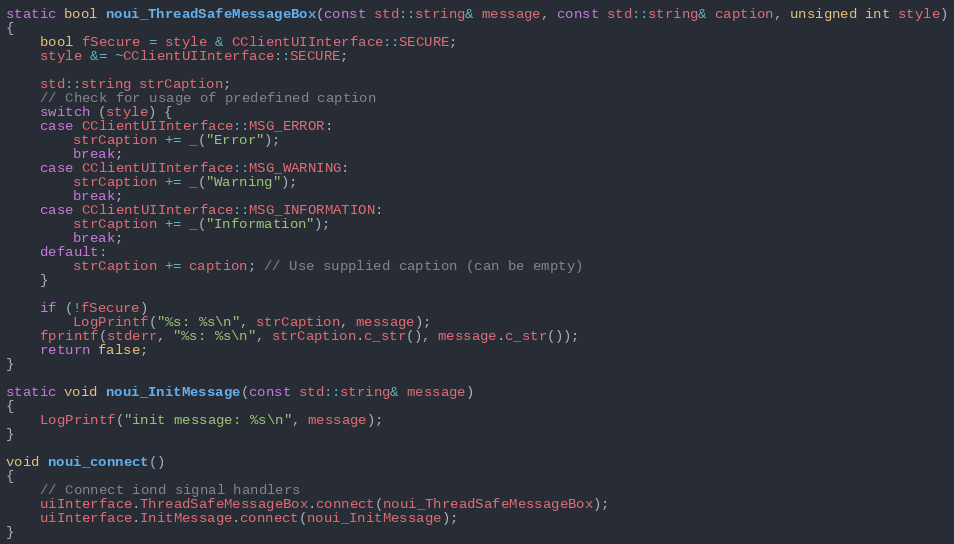Convert code to text. <code><loc_0><loc_0><loc_500><loc_500><_C++_>static bool noui_ThreadSafeMessageBox(const std::string& message, const std::string& caption, unsigned int style)
{
    bool fSecure = style & CClientUIInterface::SECURE;
    style &= ~CClientUIInterface::SECURE;

    std::string strCaption;
    // Check for usage of predefined caption
    switch (style) {
    case CClientUIInterface::MSG_ERROR:
        strCaption += _("Error");
        break;
    case CClientUIInterface::MSG_WARNING:
        strCaption += _("Warning");
        break;
    case CClientUIInterface::MSG_INFORMATION:
        strCaption += _("Information");
        break;
    default:
        strCaption += caption; // Use supplied caption (can be empty)
    }

    if (!fSecure)
        LogPrintf("%s: %s\n", strCaption, message);
    fprintf(stderr, "%s: %s\n", strCaption.c_str(), message.c_str());
    return false;
}

static void noui_InitMessage(const std::string& message)
{
    LogPrintf("init message: %s\n", message);
}

void noui_connect()
{
    // Connect iond signal handlers
    uiInterface.ThreadSafeMessageBox.connect(noui_ThreadSafeMessageBox);
    uiInterface.InitMessage.connect(noui_InitMessage);
}
</code> 